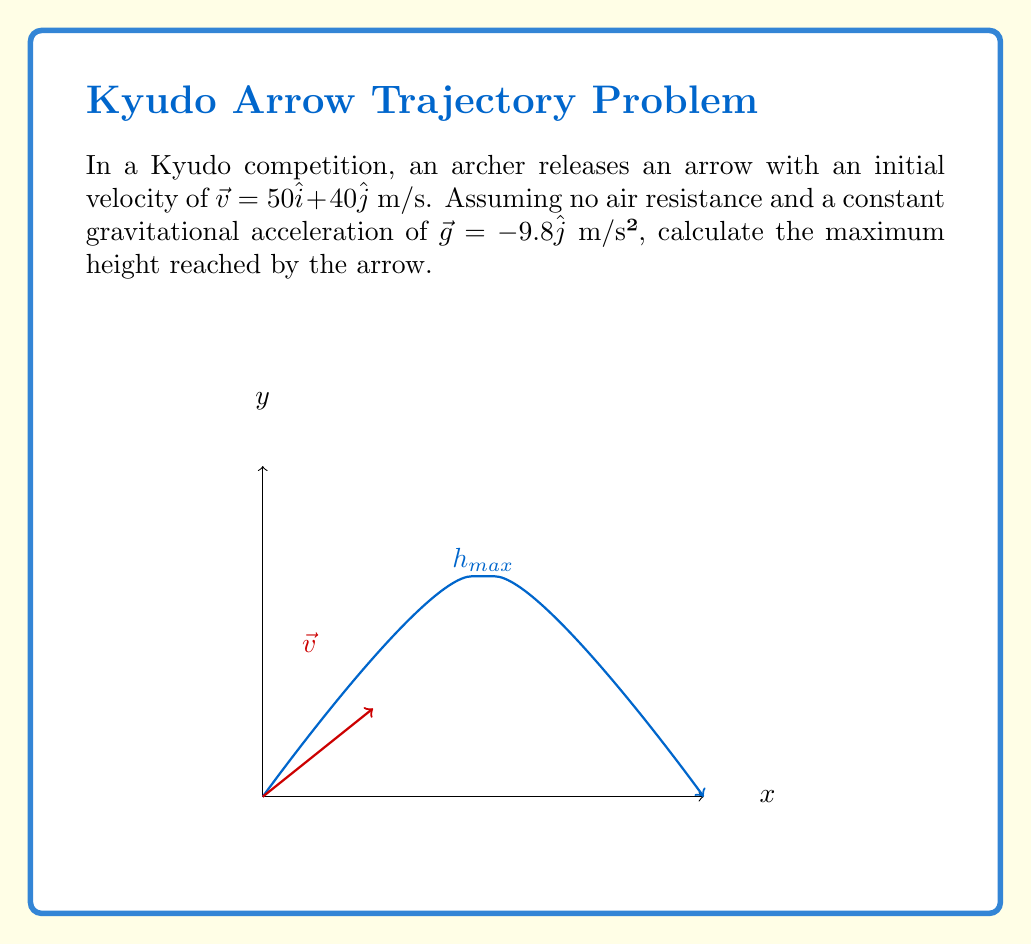Provide a solution to this math problem. Let's approach this step-by-step:

1) The maximum height is reached when the vertical component of velocity becomes zero. We need to find the time this occurs and then calculate the height at that time.

2) The vertical component of velocity at any time $t$ is given by:
   $$v_y(t) = v_{0y} + g_yt$$
   where $v_{0y}$ is the initial vertical velocity and $g_y$ is the vertical acceleration due to gravity.

3) We have $v_{0y} = 40$ m/s and $g_y = -9.8$ m/s². Let's set $v_y(t) = 0$ to find the time of maximum height:
   $$0 = 40 - 9.8t$$
   $$9.8t = 40$$
   $$t = \frac{40}{9.8} \approx 4.08 \text{ s}$$

4) Now that we know the time, we can calculate the maximum height using the equation:
   $$y(t) = y_0 + v_{0y}t + \frac{1}{2}g_yt^2$$
   where $y_0$ is the initial height (0 in this case).

5) Substituting our values:
   $$y(4.08) = 0 + 40(4.08) + \frac{1}{2}(-9.8)(4.08)^2$$
   $$= 163.2 - 81.6$$
   $$= 81.6 \text{ m}$$

Therefore, the maximum height reached by the arrow is approximately 81.6 meters.
Answer: $81.6$ m 